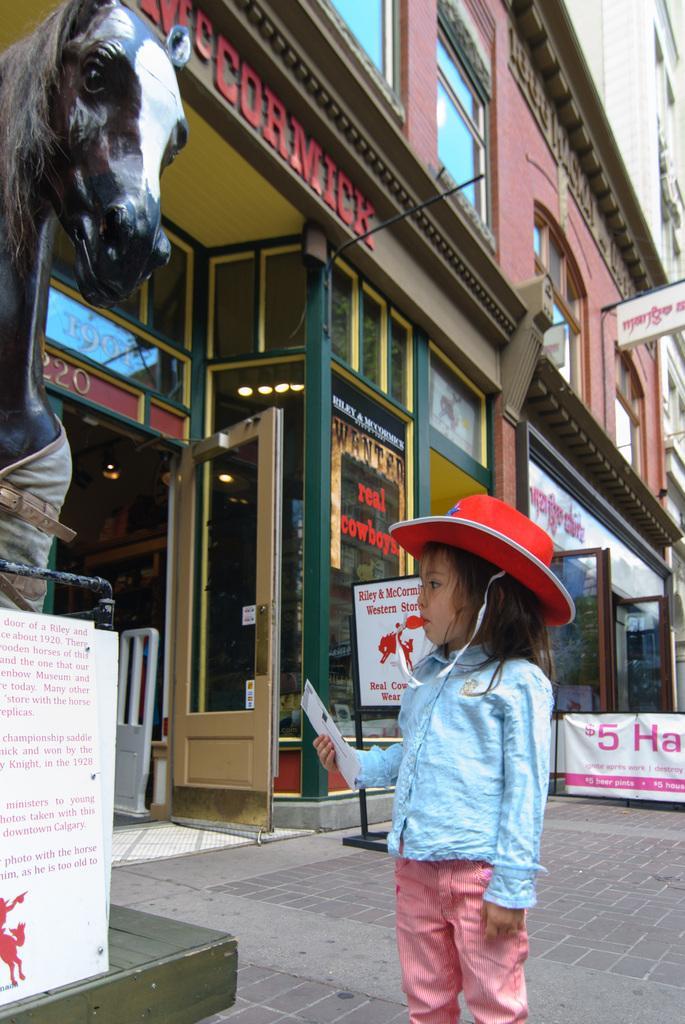Please provide a concise description of this image. A little girl is standing and observing the statue of a horse. This girl wore a red color hat. This is the building. 